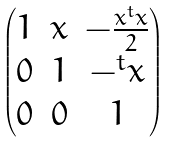<formula> <loc_0><loc_0><loc_500><loc_500>\begin{pmatrix} 1 & x & - \frac { x ^ { t } x } { 2 } \\ 0 & 1 & - ^ { t } x \\ 0 & 0 & 1 \end{pmatrix}</formula> 